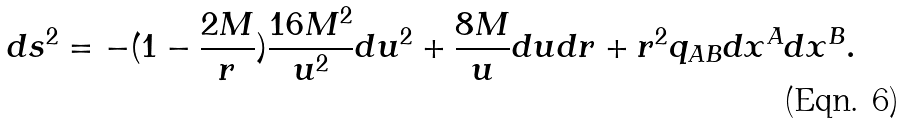Convert formula to latex. <formula><loc_0><loc_0><loc_500><loc_500>d s ^ { 2 } = - ( 1 - \frac { 2 M } { r } ) \frac { 1 6 M ^ { 2 } } { u ^ { 2 } } d u ^ { 2 } + \frac { 8 M } { u } d u d r + r ^ { 2 } q _ { A B } d x ^ { A } d x ^ { B } .</formula> 